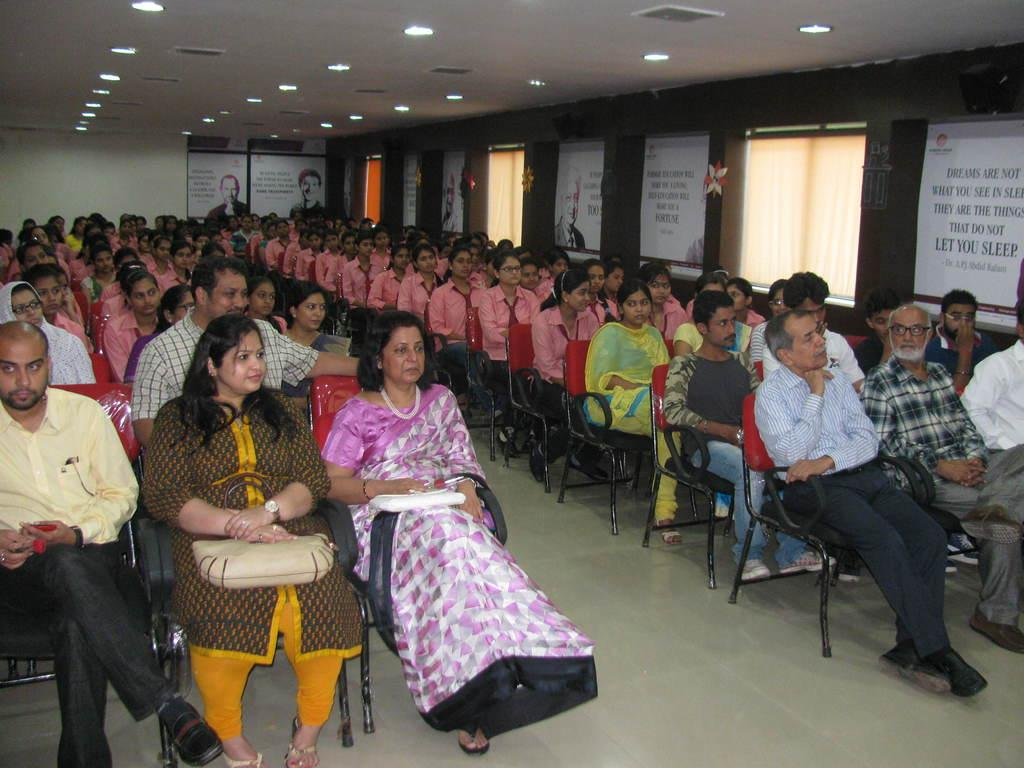What are the people in the image doing? The people in the image are sitting on chairs. What can be seen written on a wall in the image? There is text written on a wall in the image. What is visible at the top of the image? There are lights visible at the top of the image. What type of store is depicted in the image? There is no store present in the image; it features people sitting on chairs and text on a wall. Who is the creator of the text on the wall in the image? The creator of the text on the wall is not mentioned or visible in the image. 